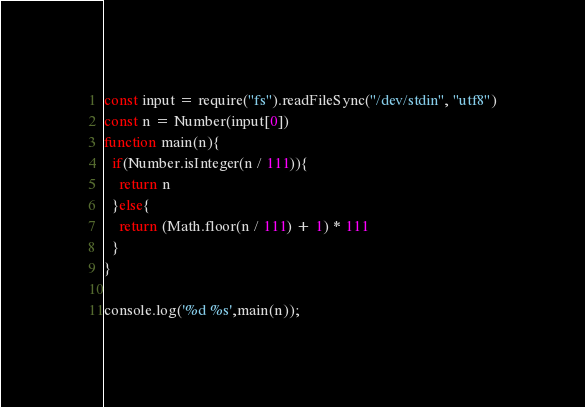<code> <loc_0><loc_0><loc_500><loc_500><_JavaScript_>const input = require("fs").readFileSync("/dev/stdin", "utf8")
const n = Number(input[0])
function main(n){
  if(Number.isInteger(n / 111)){
  	return n
  }else{
 	return (Math.floor(n / 111) + 1) * 111
  }
}
        
console.log('%d %s',main(n));</code> 